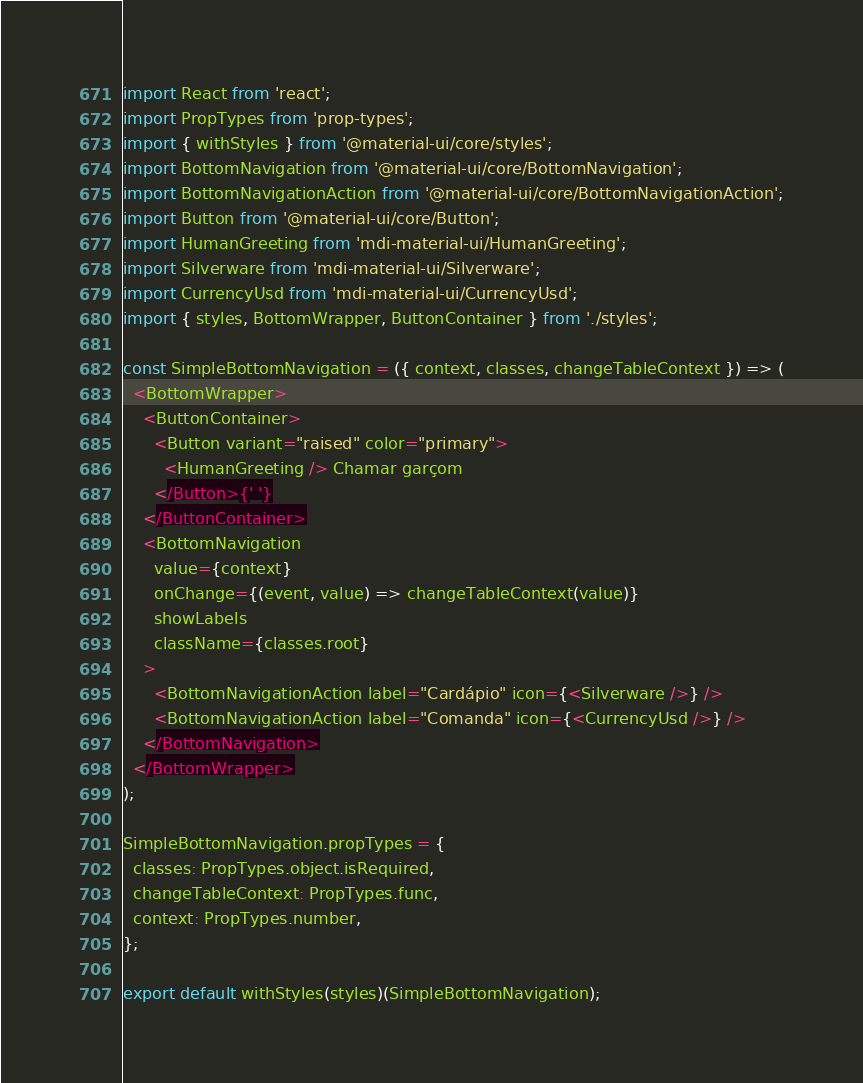Convert code to text. <code><loc_0><loc_0><loc_500><loc_500><_JavaScript_>import React from 'react';
import PropTypes from 'prop-types';
import { withStyles } from '@material-ui/core/styles';
import BottomNavigation from '@material-ui/core/BottomNavigation';
import BottomNavigationAction from '@material-ui/core/BottomNavigationAction';
import Button from '@material-ui/core/Button';
import HumanGreeting from 'mdi-material-ui/HumanGreeting';
import Silverware from 'mdi-material-ui/Silverware';
import CurrencyUsd from 'mdi-material-ui/CurrencyUsd';
import { styles, BottomWrapper, ButtonContainer } from './styles';

const SimpleBottomNavigation = ({ context, classes, changeTableContext }) => (
  <BottomWrapper>
    <ButtonContainer>
      <Button variant="raised" color="primary">
        <HumanGreeting /> Chamar garçom
      </Button>{' '}
    </ButtonContainer>
    <BottomNavigation
      value={context}
      onChange={(event, value) => changeTableContext(value)}
      showLabels
      className={classes.root}
    >
      <BottomNavigationAction label="Cardápio" icon={<Silverware />} />
      <BottomNavigationAction label="Comanda" icon={<CurrencyUsd />} />
    </BottomNavigation>
  </BottomWrapper>
);

SimpleBottomNavigation.propTypes = {
  classes: PropTypes.object.isRequired,
  changeTableContext: PropTypes.func,
  context: PropTypes.number,
};

export default withStyles(styles)(SimpleBottomNavigation);
</code> 